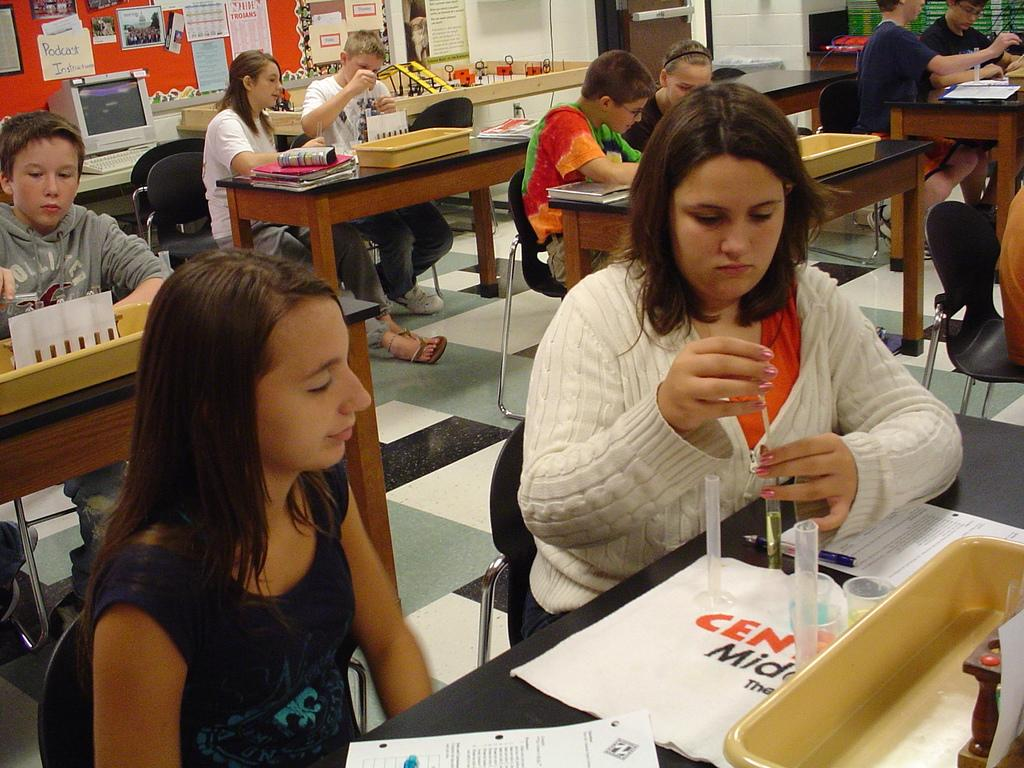What are the people in the image doing? The people in the image are sitting on chairs. What can be seen on the tables in the image? There are items on the tables in the image. What electronic devices are visible in the background of the image? There is a monitor and a keyboard in the background of the image. What type of soap is being used by the people in the image? There is no soap present in the image; it features people sitting on chairs with items on the tables and electronic devices in the background. 